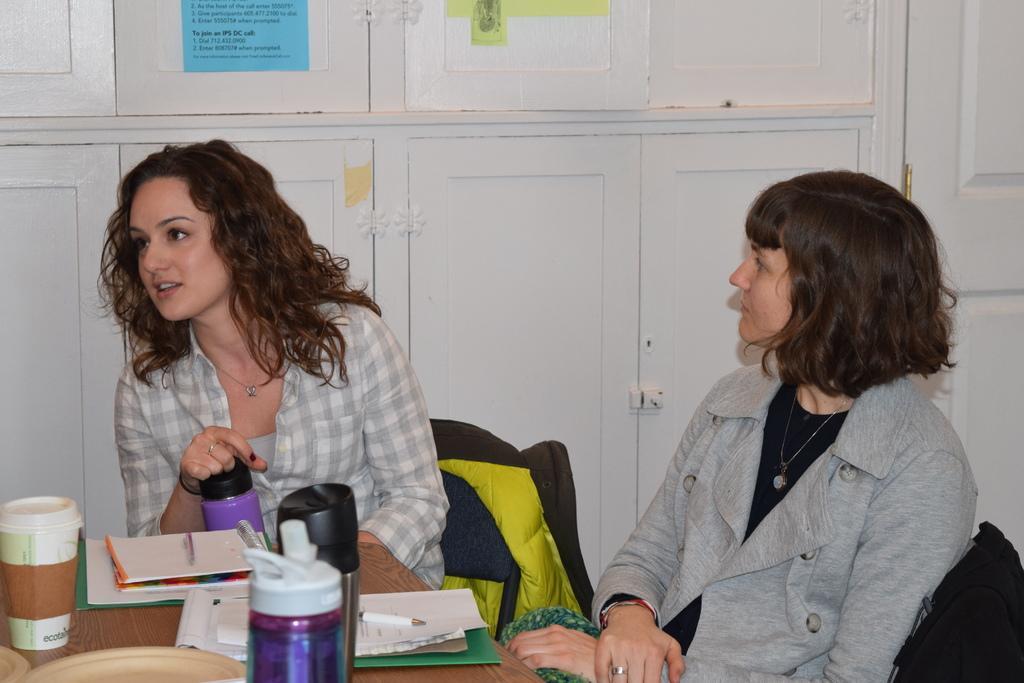Describe this image in one or two sentences. There are two women sat on chair in front of table which has bottles,papers and coffee mug on it. And on to the the background there are cupboard. 